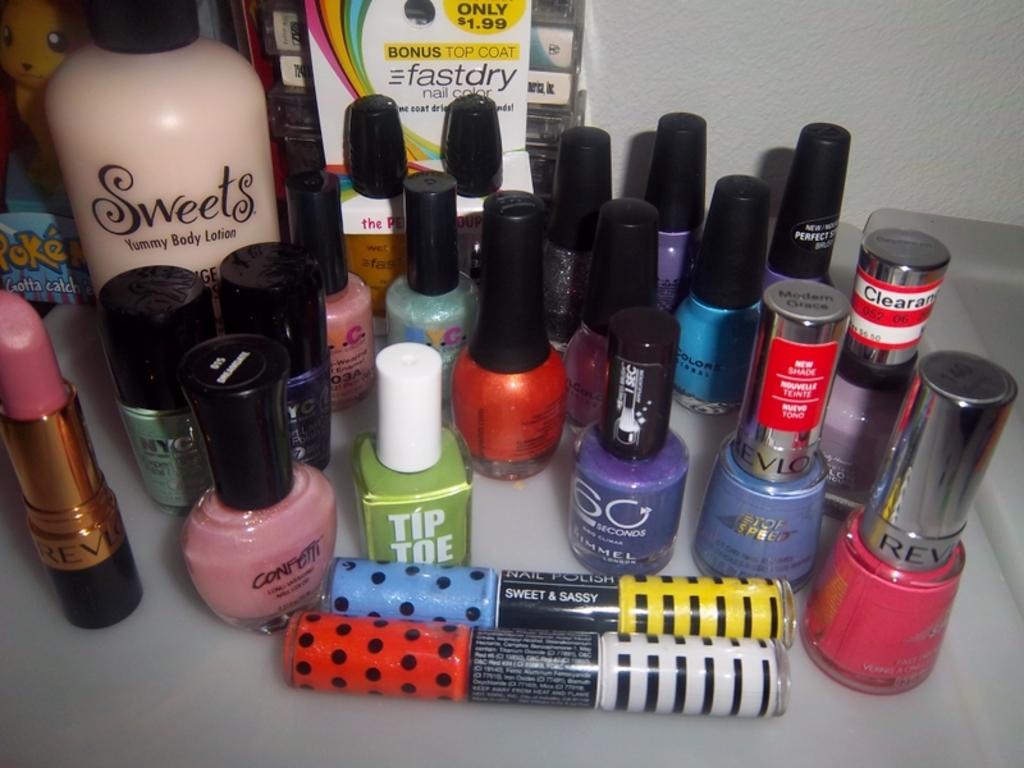How much is that fast dry product?
Offer a very short reply. $1.99. What large word is written on the large pink bottle to the left?
Your answer should be compact. Sweets. 